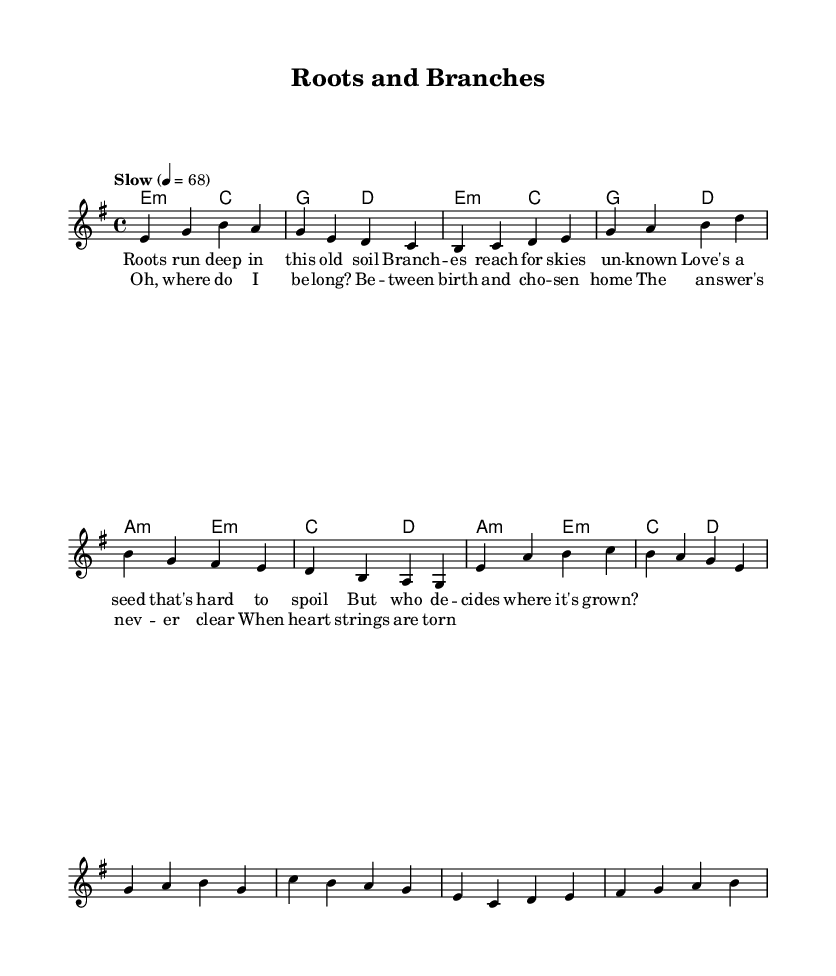What is the key signature of this music? The key signature is E minor, which has one sharp. This can be identified by looking at the key signature section at the beginning of the score.
Answer: E minor What is the time signature of this music? The time signature is 4/4, indicated near the beginning of the score. This means there are four beats per measure, and the quarter note gets one beat.
Answer: 4/4 What tempo marking is indicated for this piece? The tempo marking says "Slow," and the specific tempo is given as quarter note equals 68 beats per minute, which is also noted in the score.
Answer: Slow, quarter note = 68 How many measures are in the verse section of the composition? The verse section consists of four measures, as can be counted directly from the melody and harmonies specified in that section.
Answer: Four What is the structure of the piece? The piece contains verses followed by a chorus, which is a common structure in Blues music, emphasizing storytelling and emotional expression. The overall format is Verse-Chorus.
Answer: Verse-Chorus What is the lyrical theme of the piece? The lyrics convey a sense of longing and questioning about belonging and familial ties, reflecting the emotional struggle between biological and adoptive connections.
Answer: Belonging and family What type of chord is used in the first measure? The first measure contains an E minor chord, identifiable by the chord symbols provided in the harmonies section, which accompany the melody.
Answer: E minor 